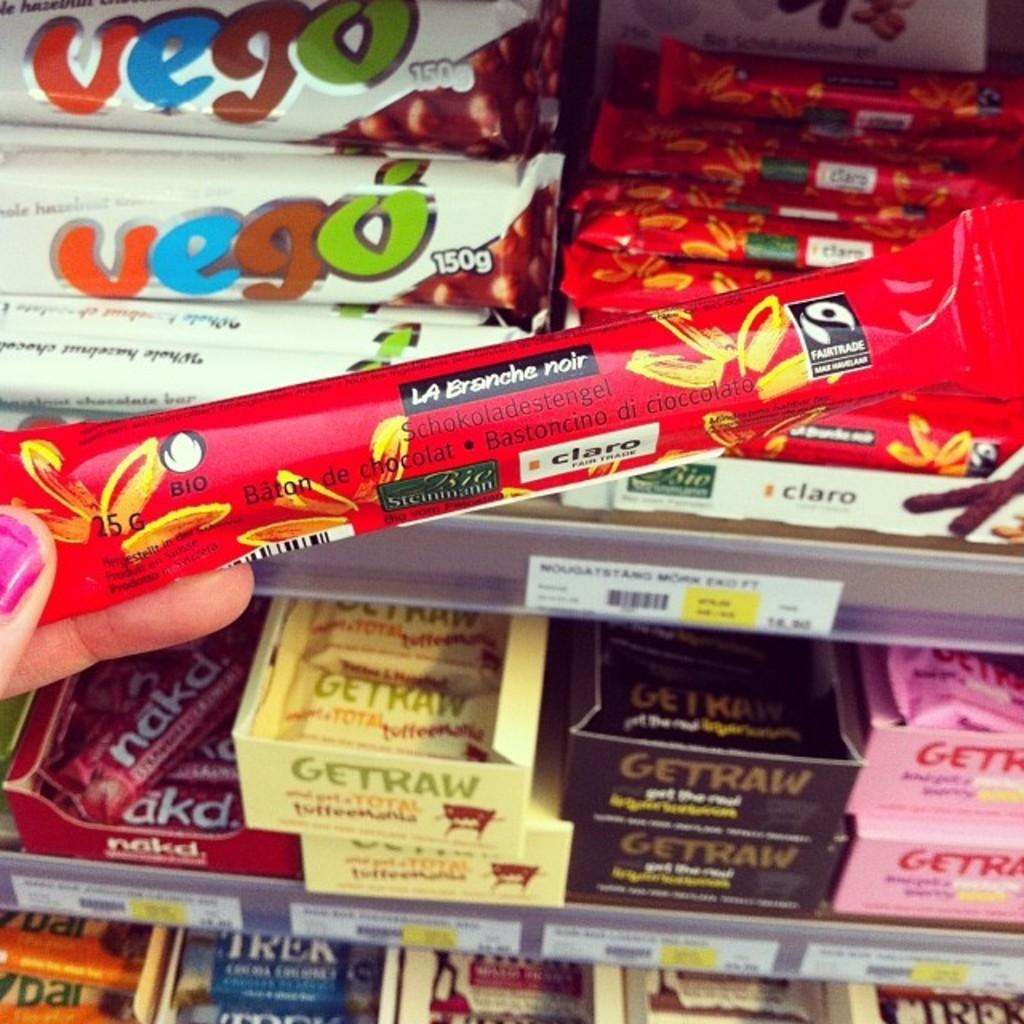What is on the shelf in the image? There are food items on a shelf in the image. How are the food items packaged? The food items are wrapped in a cover. What else can be seen in the image besides the food items? There are boxes visible in the image. Whose fingers are present in the image? Human fingers are present in the image. What type of bubble can be seen floating near the food items in the image? There is no bubble present in the image. What kind of oatmeal is being prepared in the image? There is no oatmeal or preparation process visible in the image. 